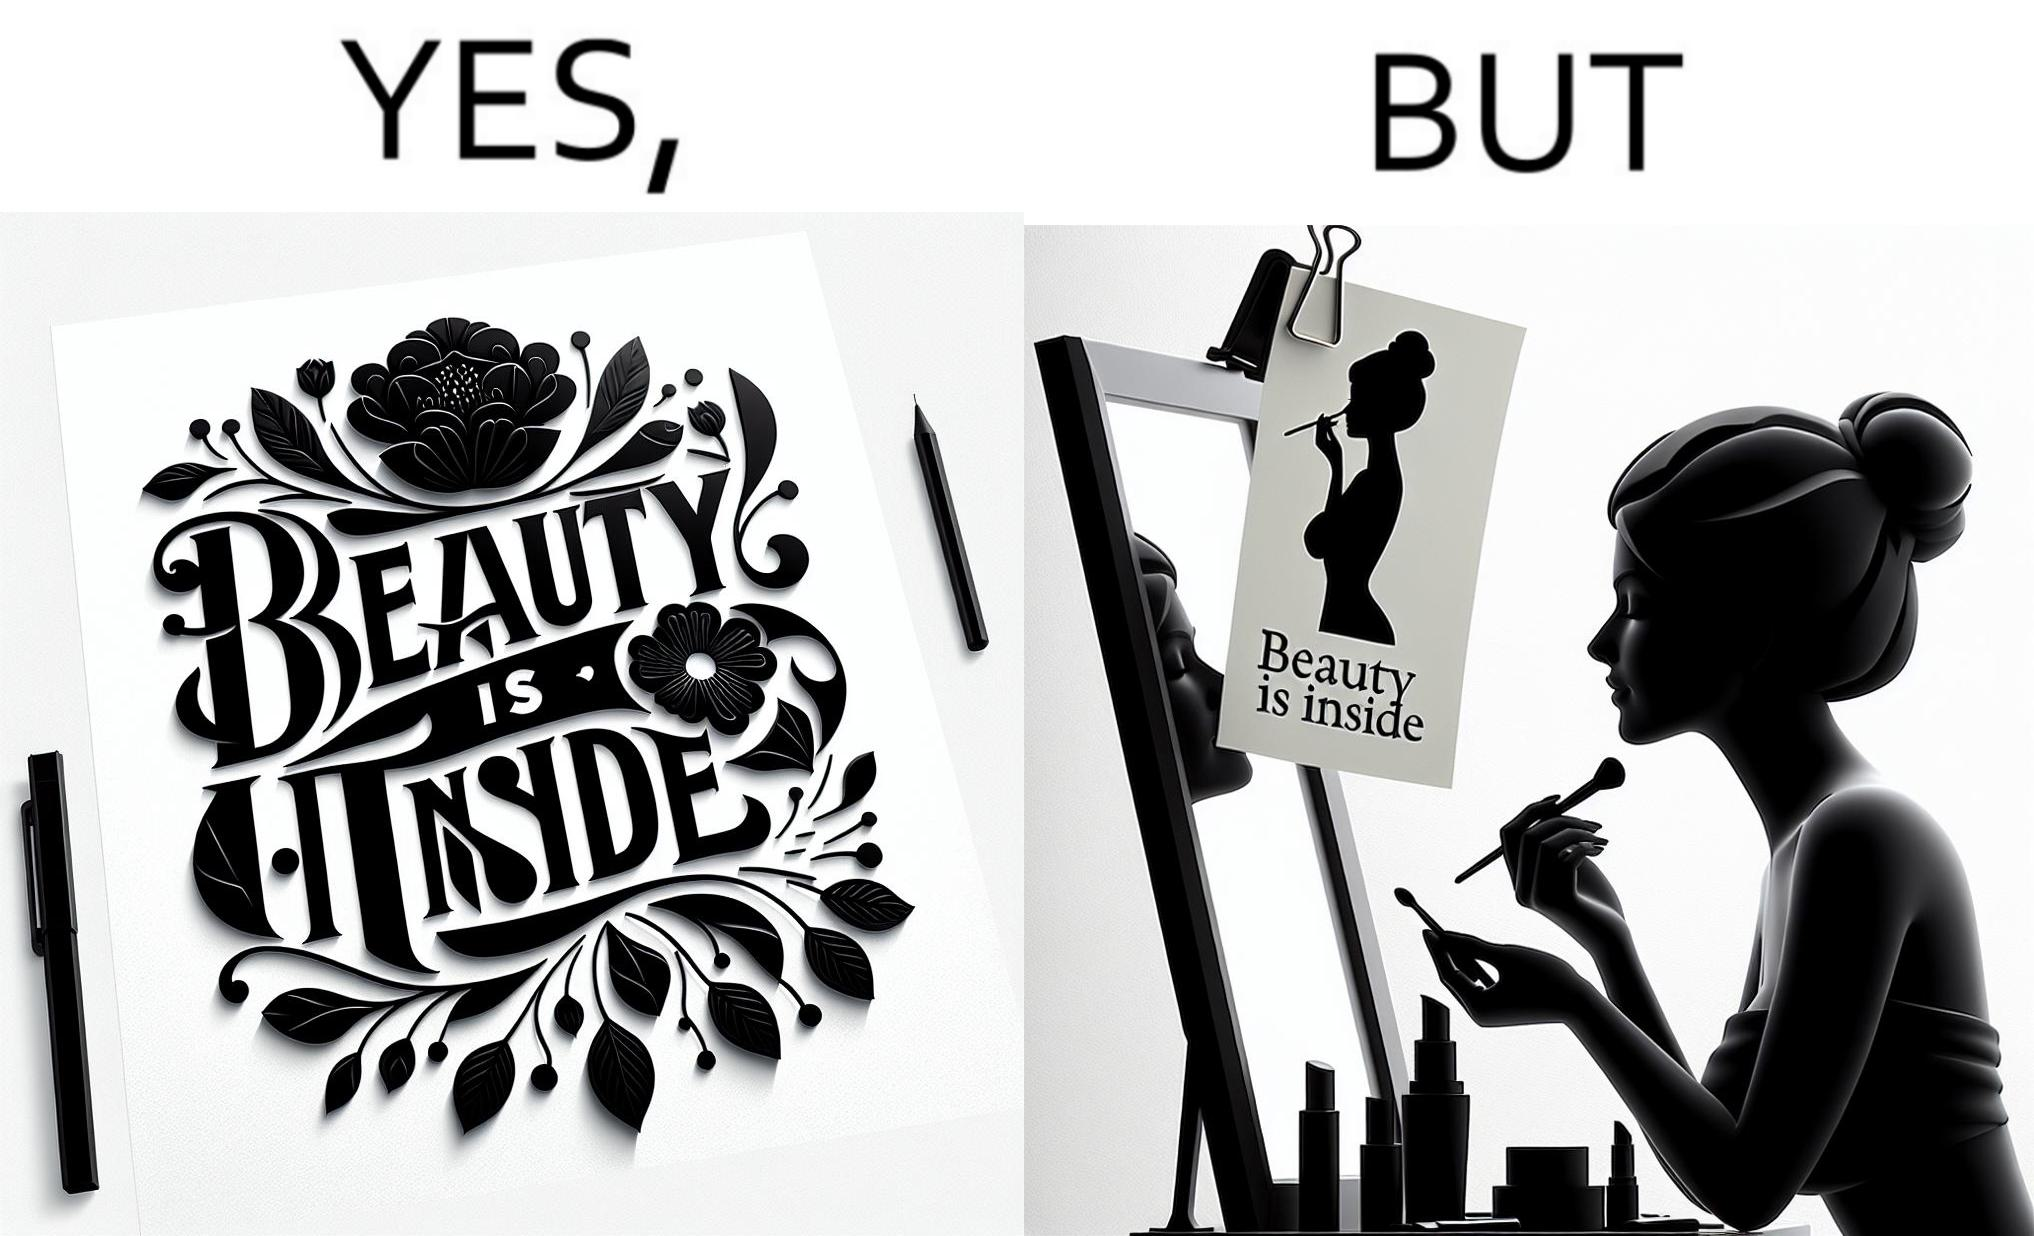Describe the satirical element in this image. The image is satirical because while the text on the paper says that beauty lies inside, the woman ignores the note and continues to apply makeup to improve her outer beauty. 